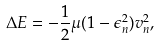<formula> <loc_0><loc_0><loc_500><loc_500>\Delta E = - \frac { 1 } { 2 } \mu ( 1 - \epsilon _ { n } ^ { 2 } ) v _ { n } ^ { 2 } ,</formula> 